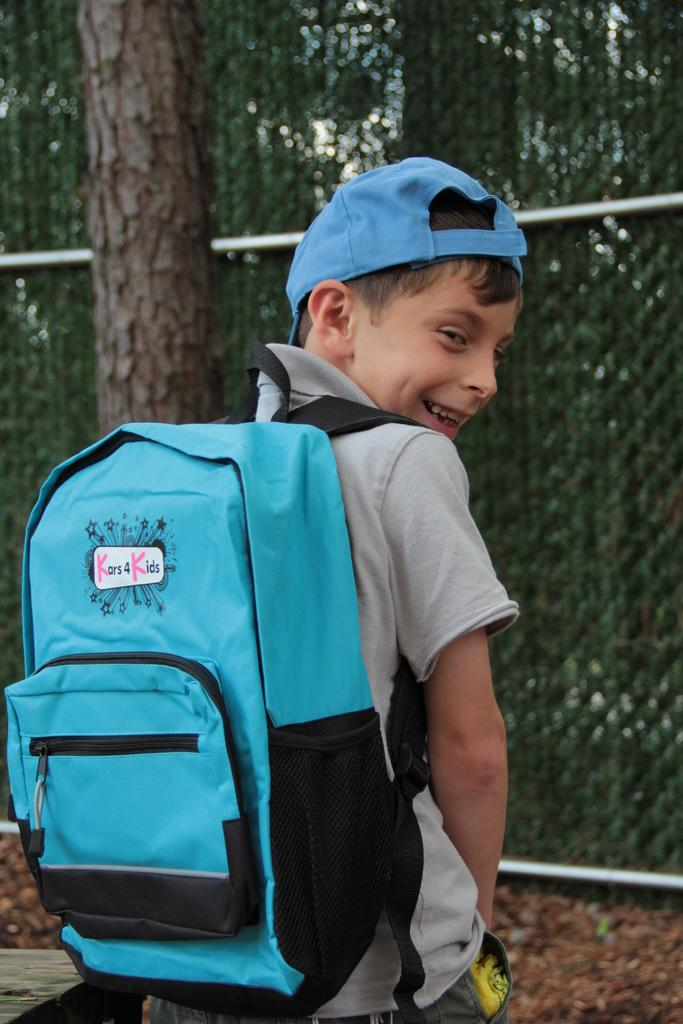What is the main subject of the image? There is a person in the image. What is the person wearing in the image? The person is wearing a bag. What is the person doing in the image? The person is standing. What type of creature is the person arguing with in the image? There is no creature present in the image, and the person is not engaged in an argument. 